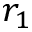<formula> <loc_0><loc_0><loc_500><loc_500>r _ { 1 }</formula> 